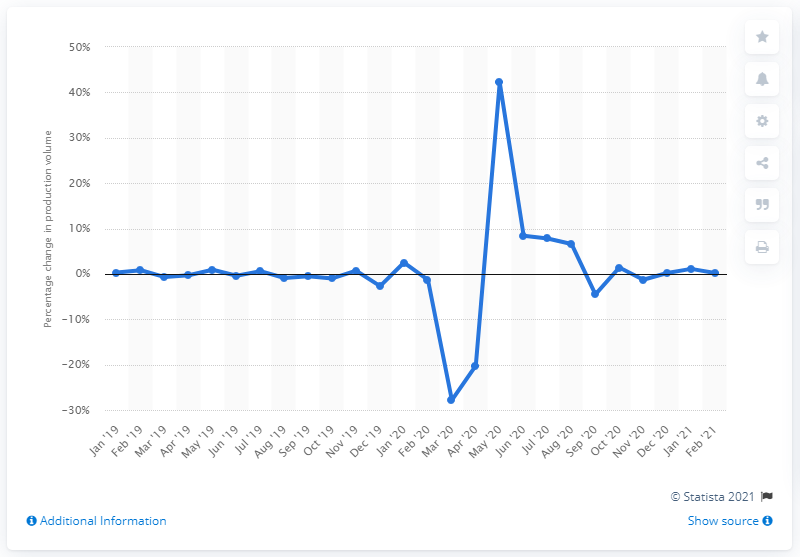Highlight a few significant elements in this photo. Italy's industrial production experienced a slight increase of 0.2% in February 2021. 